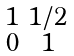Convert formula to latex. <formula><loc_0><loc_0><loc_500><loc_500>\begin{smallmatrix} 1 & 1 / 2 \\ 0 & 1 \end{smallmatrix}</formula> 